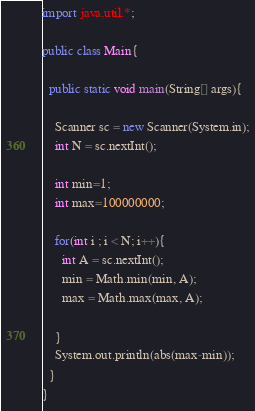Convert code to text. <code><loc_0><loc_0><loc_500><loc_500><_Java_>import java.util.*;

public class Main{
  
  public static void main(String[] args){
    
    Scanner sc = new Scanner(System.in);
    int N = sc.nextInt();

    int min=1;
    int max=100000000;
    
    for(int i ; i < N; i++){
      int A = sc.nextInt();
      min = Math.min(min, A);
      max = Math.max(max, A);
     
    }
    System.out.println(abs(max-min));
  }
}</code> 